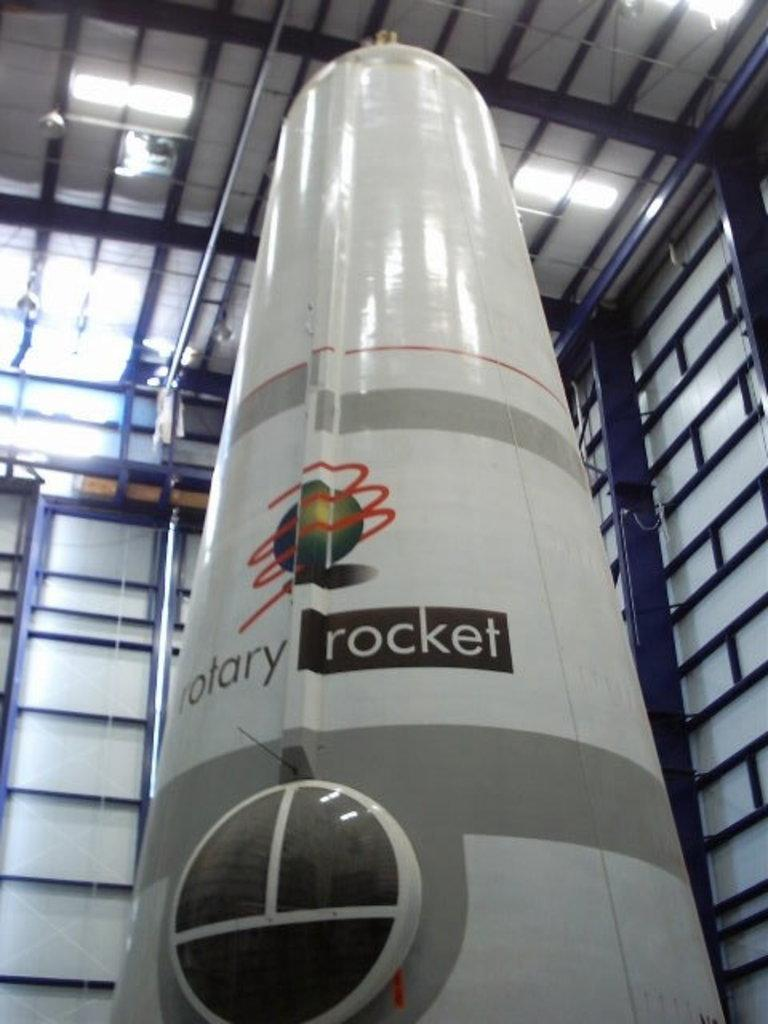What is the main object in the image that resembles a rocket? There is an object in the image that resembles a rocket. Are there any markings or text on the rocket-like object? Yes, there is writing on the rocket-like object. What can be seen in the background of the image? There are rods visible in the background of the image. What type of illumination is present in the image? There are lights present in the image. What type of popcorn is being served in the image? There is no popcorn present in the image. What emotion is the rocket-like object experiencing in the image? The rocket-like object is an inanimate object and does not experience emotions like shame or pleasure. 